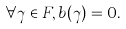<formula> <loc_0><loc_0><loc_500><loc_500>\forall \gamma \in F , b ( \gamma ) = 0 .</formula> 